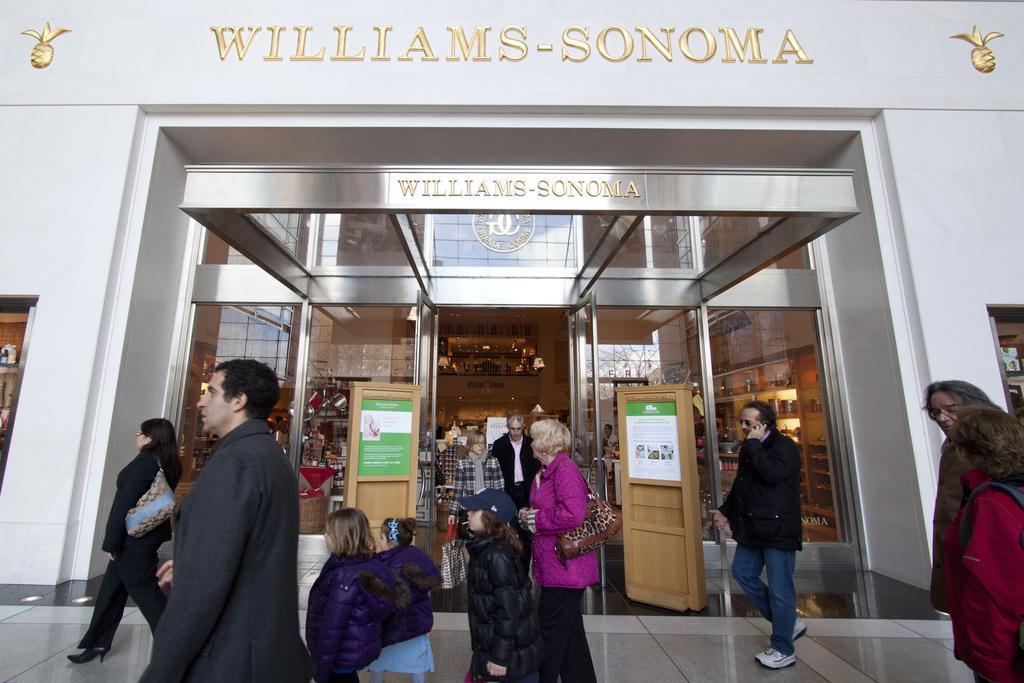In one or two sentences, can you explain what this image depicts? In front of the picture, we see the people are standing. The woman on the left side is wearing a bag and she is walking. In the middle, we see a man and a woman are standing. Beside them, we see the glass doors, wooden stands and the board in white and green color with some text written. On the left side, we see a white wall. In the background, we see the glass door from which we can see the racks, chairs and a wall. At the top, we see some text written as "WILLIAMS SONOMA". 